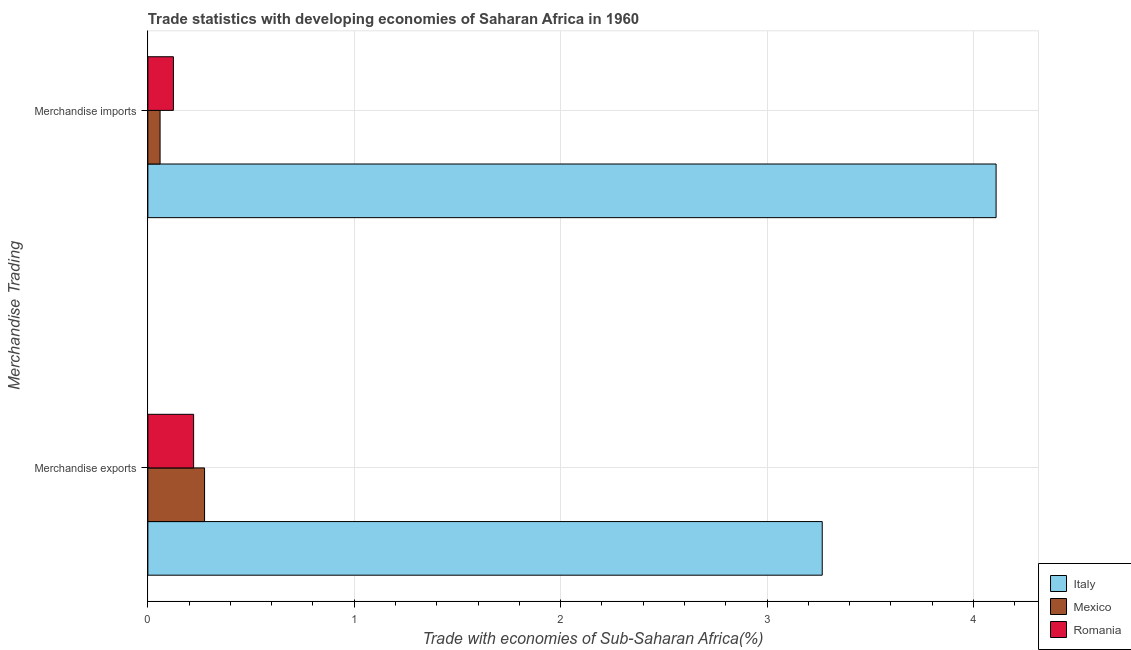How many different coloured bars are there?
Keep it short and to the point. 3. Are the number of bars per tick equal to the number of legend labels?
Keep it short and to the point. Yes. How many bars are there on the 2nd tick from the bottom?
Offer a very short reply. 3. What is the merchandise imports in Mexico?
Provide a succinct answer. 0.06. Across all countries, what is the maximum merchandise imports?
Make the answer very short. 4.11. Across all countries, what is the minimum merchandise exports?
Provide a short and direct response. 0.22. In which country was the merchandise exports maximum?
Your response must be concise. Italy. In which country was the merchandise exports minimum?
Offer a terse response. Romania. What is the total merchandise imports in the graph?
Provide a short and direct response. 4.29. What is the difference between the merchandise imports in Italy and that in Romania?
Make the answer very short. 3.99. What is the difference between the merchandise imports in Italy and the merchandise exports in Romania?
Ensure brevity in your answer.  3.89. What is the average merchandise exports per country?
Keep it short and to the point. 1.25. What is the difference between the merchandise exports and merchandise imports in Romania?
Provide a short and direct response. 0.1. What is the ratio of the merchandise imports in Mexico to that in Italy?
Your answer should be very brief. 0.01. In how many countries, is the merchandise imports greater than the average merchandise imports taken over all countries?
Provide a short and direct response. 1. What does the 1st bar from the top in Merchandise exports represents?
Keep it short and to the point. Romania. How many bars are there?
Ensure brevity in your answer.  6. Are all the bars in the graph horizontal?
Your response must be concise. Yes. How many countries are there in the graph?
Make the answer very short. 3. What is the difference between two consecutive major ticks on the X-axis?
Offer a terse response. 1. Does the graph contain any zero values?
Your answer should be compact. No. Where does the legend appear in the graph?
Ensure brevity in your answer.  Bottom right. What is the title of the graph?
Ensure brevity in your answer.  Trade statistics with developing economies of Saharan Africa in 1960. Does "Grenada" appear as one of the legend labels in the graph?
Give a very brief answer. No. What is the label or title of the X-axis?
Offer a very short reply. Trade with economies of Sub-Saharan Africa(%). What is the label or title of the Y-axis?
Offer a terse response. Merchandise Trading. What is the Trade with economies of Sub-Saharan Africa(%) of Italy in Merchandise exports?
Your response must be concise. 3.27. What is the Trade with economies of Sub-Saharan Africa(%) of Mexico in Merchandise exports?
Provide a succinct answer. 0.27. What is the Trade with economies of Sub-Saharan Africa(%) in Romania in Merchandise exports?
Give a very brief answer. 0.22. What is the Trade with economies of Sub-Saharan Africa(%) in Italy in Merchandise imports?
Ensure brevity in your answer.  4.11. What is the Trade with economies of Sub-Saharan Africa(%) in Mexico in Merchandise imports?
Your response must be concise. 0.06. What is the Trade with economies of Sub-Saharan Africa(%) in Romania in Merchandise imports?
Provide a short and direct response. 0.12. Across all Merchandise Trading, what is the maximum Trade with economies of Sub-Saharan Africa(%) of Italy?
Your response must be concise. 4.11. Across all Merchandise Trading, what is the maximum Trade with economies of Sub-Saharan Africa(%) in Mexico?
Offer a terse response. 0.27. Across all Merchandise Trading, what is the maximum Trade with economies of Sub-Saharan Africa(%) of Romania?
Keep it short and to the point. 0.22. Across all Merchandise Trading, what is the minimum Trade with economies of Sub-Saharan Africa(%) in Italy?
Give a very brief answer. 3.27. Across all Merchandise Trading, what is the minimum Trade with economies of Sub-Saharan Africa(%) of Mexico?
Offer a very short reply. 0.06. Across all Merchandise Trading, what is the minimum Trade with economies of Sub-Saharan Africa(%) of Romania?
Provide a succinct answer. 0.12. What is the total Trade with economies of Sub-Saharan Africa(%) of Italy in the graph?
Give a very brief answer. 7.38. What is the total Trade with economies of Sub-Saharan Africa(%) of Mexico in the graph?
Make the answer very short. 0.33. What is the total Trade with economies of Sub-Saharan Africa(%) in Romania in the graph?
Your answer should be very brief. 0.35. What is the difference between the Trade with economies of Sub-Saharan Africa(%) in Italy in Merchandise exports and that in Merchandise imports?
Make the answer very short. -0.84. What is the difference between the Trade with economies of Sub-Saharan Africa(%) in Mexico in Merchandise exports and that in Merchandise imports?
Your answer should be very brief. 0.22. What is the difference between the Trade with economies of Sub-Saharan Africa(%) of Romania in Merchandise exports and that in Merchandise imports?
Offer a very short reply. 0.1. What is the difference between the Trade with economies of Sub-Saharan Africa(%) in Italy in Merchandise exports and the Trade with economies of Sub-Saharan Africa(%) in Mexico in Merchandise imports?
Your answer should be compact. 3.21. What is the difference between the Trade with economies of Sub-Saharan Africa(%) of Italy in Merchandise exports and the Trade with economies of Sub-Saharan Africa(%) of Romania in Merchandise imports?
Offer a terse response. 3.14. What is the difference between the Trade with economies of Sub-Saharan Africa(%) in Mexico in Merchandise exports and the Trade with economies of Sub-Saharan Africa(%) in Romania in Merchandise imports?
Your answer should be very brief. 0.15. What is the average Trade with economies of Sub-Saharan Africa(%) of Italy per Merchandise Trading?
Your answer should be compact. 3.69. What is the average Trade with economies of Sub-Saharan Africa(%) of Mexico per Merchandise Trading?
Your response must be concise. 0.17. What is the average Trade with economies of Sub-Saharan Africa(%) of Romania per Merchandise Trading?
Offer a terse response. 0.17. What is the difference between the Trade with economies of Sub-Saharan Africa(%) in Italy and Trade with economies of Sub-Saharan Africa(%) in Mexico in Merchandise exports?
Ensure brevity in your answer.  2.99. What is the difference between the Trade with economies of Sub-Saharan Africa(%) of Italy and Trade with economies of Sub-Saharan Africa(%) of Romania in Merchandise exports?
Offer a terse response. 3.05. What is the difference between the Trade with economies of Sub-Saharan Africa(%) in Mexico and Trade with economies of Sub-Saharan Africa(%) in Romania in Merchandise exports?
Your answer should be compact. 0.05. What is the difference between the Trade with economies of Sub-Saharan Africa(%) in Italy and Trade with economies of Sub-Saharan Africa(%) in Mexico in Merchandise imports?
Your response must be concise. 4.05. What is the difference between the Trade with economies of Sub-Saharan Africa(%) in Italy and Trade with economies of Sub-Saharan Africa(%) in Romania in Merchandise imports?
Offer a terse response. 3.99. What is the difference between the Trade with economies of Sub-Saharan Africa(%) in Mexico and Trade with economies of Sub-Saharan Africa(%) in Romania in Merchandise imports?
Ensure brevity in your answer.  -0.06. What is the ratio of the Trade with economies of Sub-Saharan Africa(%) of Italy in Merchandise exports to that in Merchandise imports?
Ensure brevity in your answer.  0.8. What is the ratio of the Trade with economies of Sub-Saharan Africa(%) in Mexico in Merchandise exports to that in Merchandise imports?
Offer a terse response. 4.64. What is the ratio of the Trade with economies of Sub-Saharan Africa(%) in Romania in Merchandise exports to that in Merchandise imports?
Your response must be concise. 1.79. What is the difference between the highest and the second highest Trade with economies of Sub-Saharan Africa(%) in Italy?
Your response must be concise. 0.84. What is the difference between the highest and the second highest Trade with economies of Sub-Saharan Africa(%) of Mexico?
Offer a very short reply. 0.22. What is the difference between the highest and the second highest Trade with economies of Sub-Saharan Africa(%) in Romania?
Your answer should be compact. 0.1. What is the difference between the highest and the lowest Trade with economies of Sub-Saharan Africa(%) of Italy?
Give a very brief answer. 0.84. What is the difference between the highest and the lowest Trade with economies of Sub-Saharan Africa(%) in Mexico?
Your response must be concise. 0.22. What is the difference between the highest and the lowest Trade with economies of Sub-Saharan Africa(%) of Romania?
Offer a terse response. 0.1. 